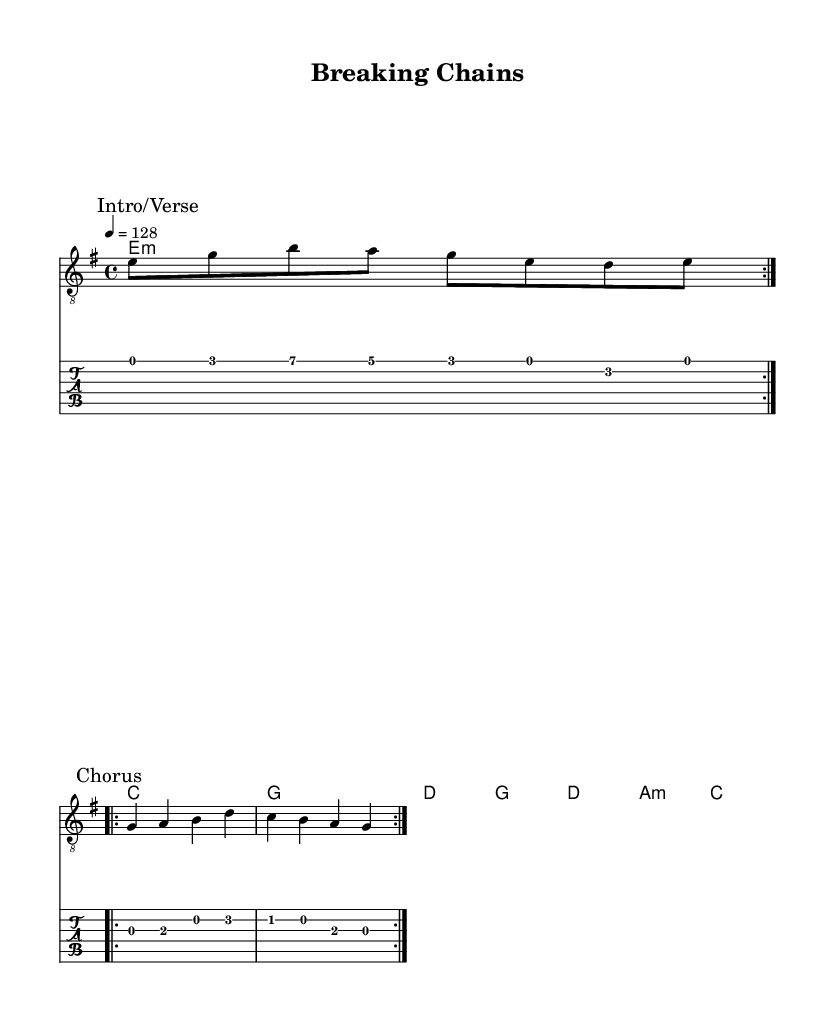What is the key signature of this music? The key signature is E minor, which contains one sharp (F#). This can be identified from the key indication stated at the beginning of the score.
Answer: E minor What is the time signature of this music? The time signature is 4/4, meaning there are four beats in a measure and the quarter note gets the beat. This information is indicated in the score just after the key signature.
Answer: 4/4 What is the tempo of the music? The tempo is 128 beats per minute. This is specified in the tempo marking at the beginning of the score under the global settings.
Answer: 128 How many chords are used in the verse? There are four chords used in the verse: E minor, C major, G major, and D major. Each chord is represented in the chord mode section of the score.
Answer: Four What is the central theme of the lyrics? The central theme of the lyrics is about labor struggles and economic injustice. The lyrics express frustration over wealth inequality and the call for economic justice, which is a prevalent theme in protest rock music.
Answer: Labor struggles Which parts of the music are repeated? The guitar riff and the chorus vocal lines are repeated twice in the score. This repetition is indicated by the "repeat volta" markings in the music sheets.
Answer: Twice What style of rock does this music represent? This music represents protest rock, which critiques wealth inequality and labor issues. The content of the lyrics and the overall theme aligns with social and political messages, typical of protest rock.
Answer: Protest rock 